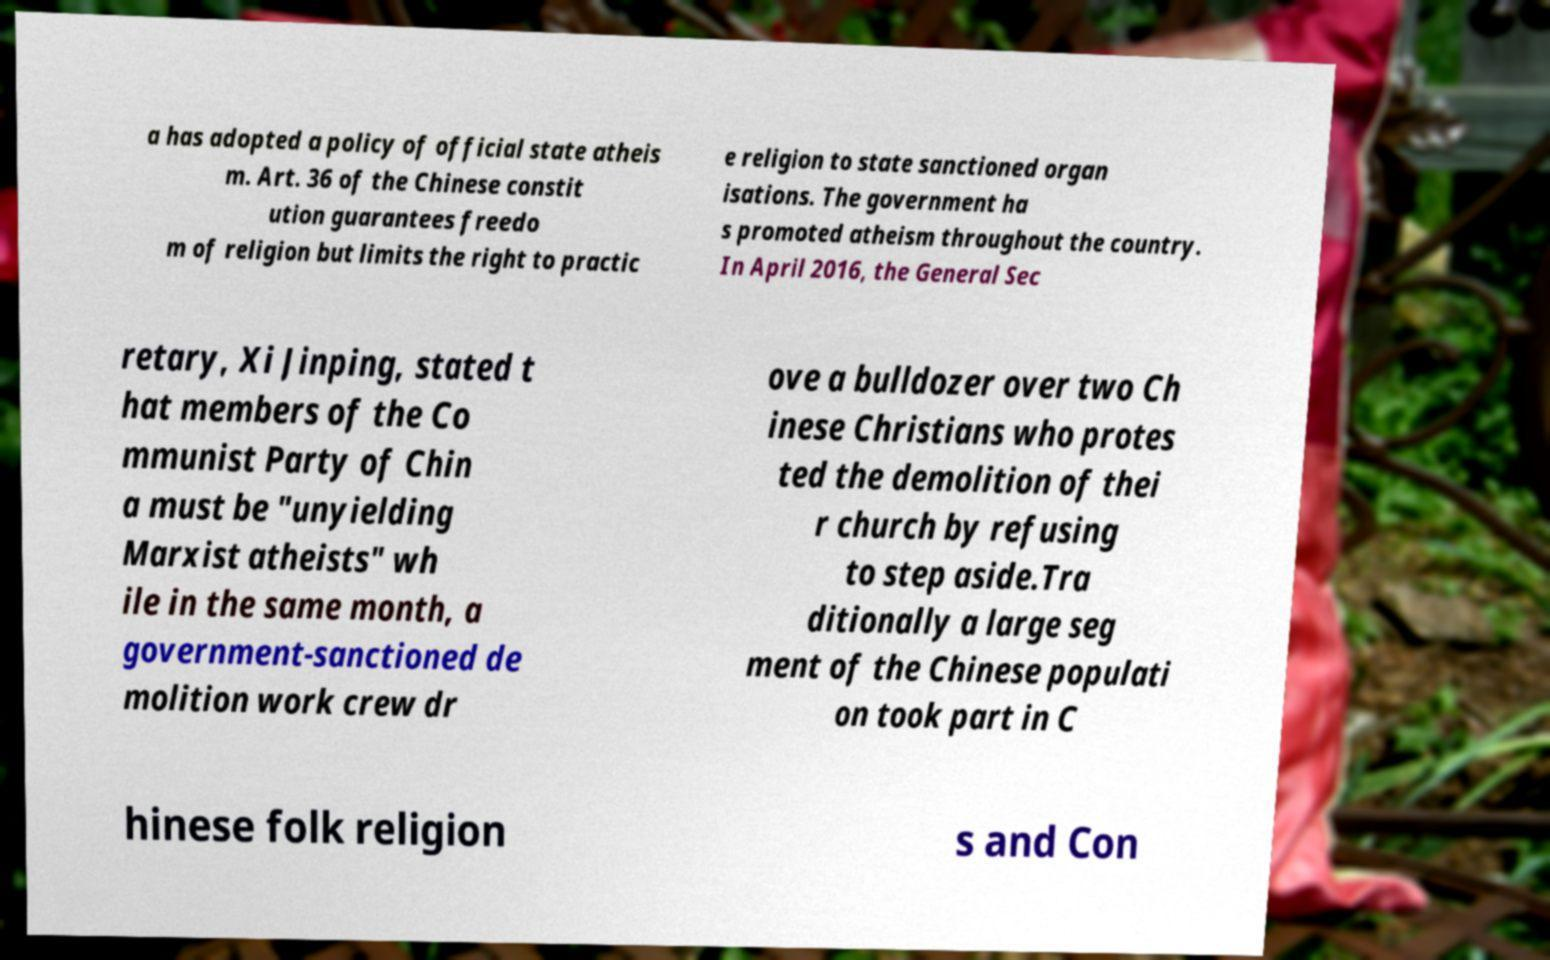What messages or text are displayed in this image? I need them in a readable, typed format. a has adopted a policy of official state atheis m. Art. 36 of the Chinese constit ution guarantees freedo m of religion but limits the right to practic e religion to state sanctioned organ isations. The government ha s promoted atheism throughout the country. In April 2016, the General Sec retary, Xi Jinping, stated t hat members of the Co mmunist Party of Chin a must be "unyielding Marxist atheists" wh ile in the same month, a government-sanctioned de molition work crew dr ove a bulldozer over two Ch inese Christians who protes ted the demolition of thei r church by refusing to step aside.Tra ditionally a large seg ment of the Chinese populati on took part in C hinese folk religion s and Con 